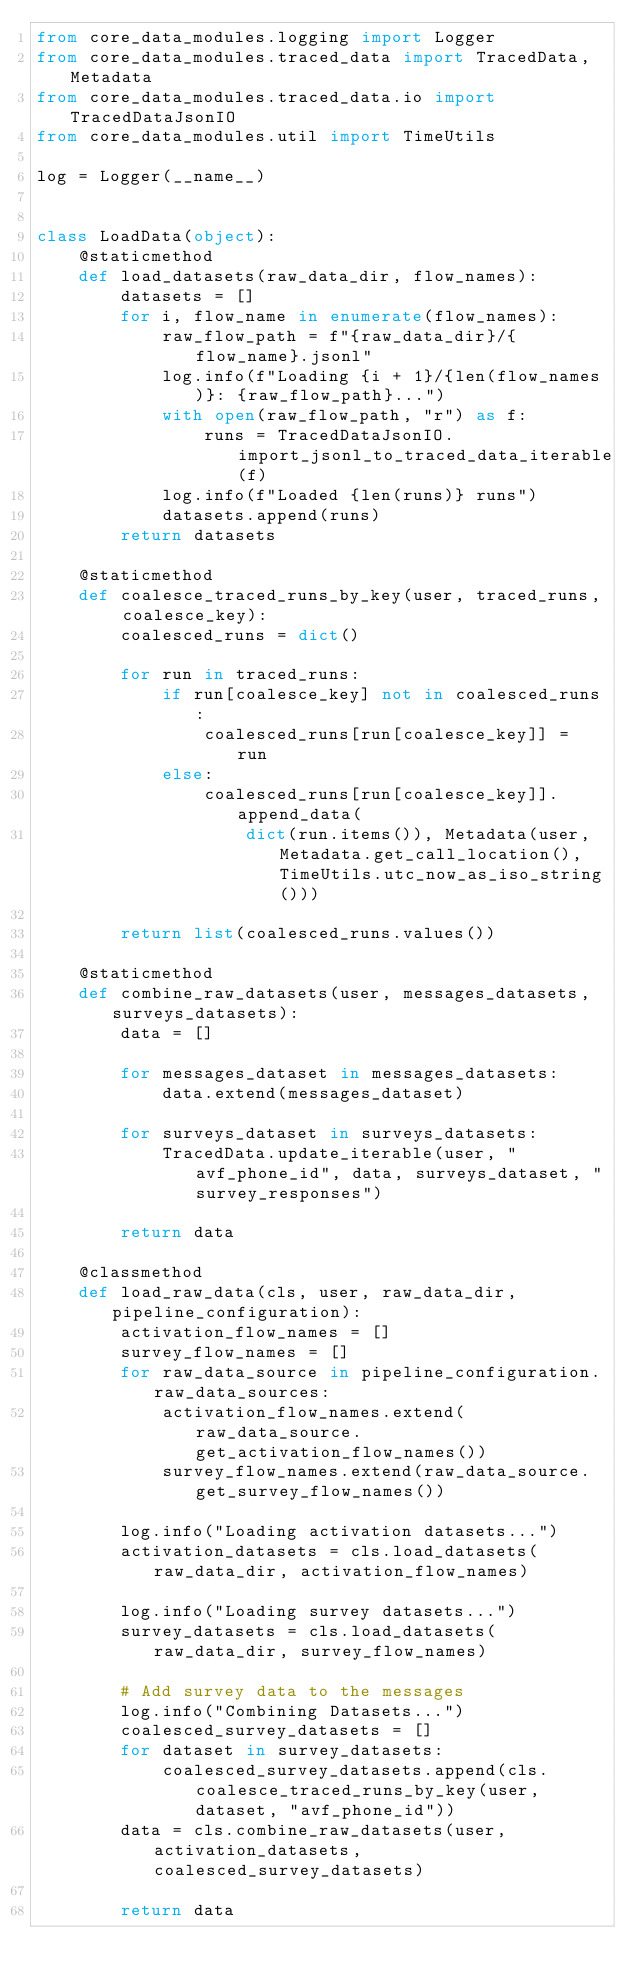<code> <loc_0><loc_0><loc_500><loc_500><_Python_>from core_data_modules.logging import Logger
from core_data_modules.traced_data import TracedData, Metadata
from core_data_modules.traced_data.io import TracedDataJsonIO
from core_data_modules.util import TimeUtils

log = Logger(__name__)


class LoadData(object):
    @staticmethod
    def load_datasets(raw_data_dir, flow_names):
        datasets = []
        for i, flow_name in enumerate(flow_names):
            raw_flow_path = f"{raw_data_dir}/{flow_name}.jsonl"
            log.info(f"Loading {i + 1}/{len(flow_names)}: {raw_flow_path}...")
            with open(raw_flow_path, "r") as f:
                runs = TracedDataJsonIO.import_jsonl_to_traced_data_iterable(f)
            log.info(f"Loaded {len(runs)} runs")
            datasets.append(runs)
        return datasets

    @staticmethod
    def coalesce_traced_runs_by_key(user, traced_runs, coalesce_key):
        coalesced_runs = dict()

        for run in traced_runs:
            if run[coalesce_key] not in coalesced_runs:
                coalesced_runs[run[coalesce_key]] = run
            else:
                coalesced_runs[run[coalesce_key]].append_data(
                    dict(run.items()), Metadata(user, Metadata.get_call_location(), TimeUtils.utc_now_as_iso_string()))

        return list(coalesced_runs.values())

    @staticmethod
    def combine_raw_datasets(user, messages_datasets, surveys_datasets):
        data = []

        for messages_dataset in messages_datasets:
            data.extend(messages_dataset)

        for surveys_dataset in surveys_datasets:
            TracedData.update_iterable(user, "avf_phone_id", data, surveys_dataset, "survey_responses")

        return data

    @classmethod
    def load_raw_data(cls, user, raw_data_dir, pipeline_configuration):
        activation_flow_names = []
        survey_flow_names = []
        for raw_data_source in pipeline_configuration.raw_data_sources:
            activation_flow_names.extend(raw_data_source.get_activation_flow_names())
            survey_flow_names.extend(raw_data_source.get_survey_flow_names())
            
        log.info("Loading activation datasets...")
        activation_datasets = cls.load_datasets(raw_data_dir, activation_flow_names)

        log.info("Loading survey datasets...")
        survey_datasets = cls.load_datasets(raw_data_dir, survey_flow_names)

        # Add survey data to the messages
        log.info("Combining Datasets...")
        coalesced_survey_datasets = []
        for dataset in survey_datasets:
            coalesced_survey_datasets.append(cls.coalesce_traced_runs_by_key(user, dataset, "avf_phone_id"))
        data = cls.combine_raw_datasets(user, activation_datasets, coalesced_survey_datasets)

        return data
</code> 